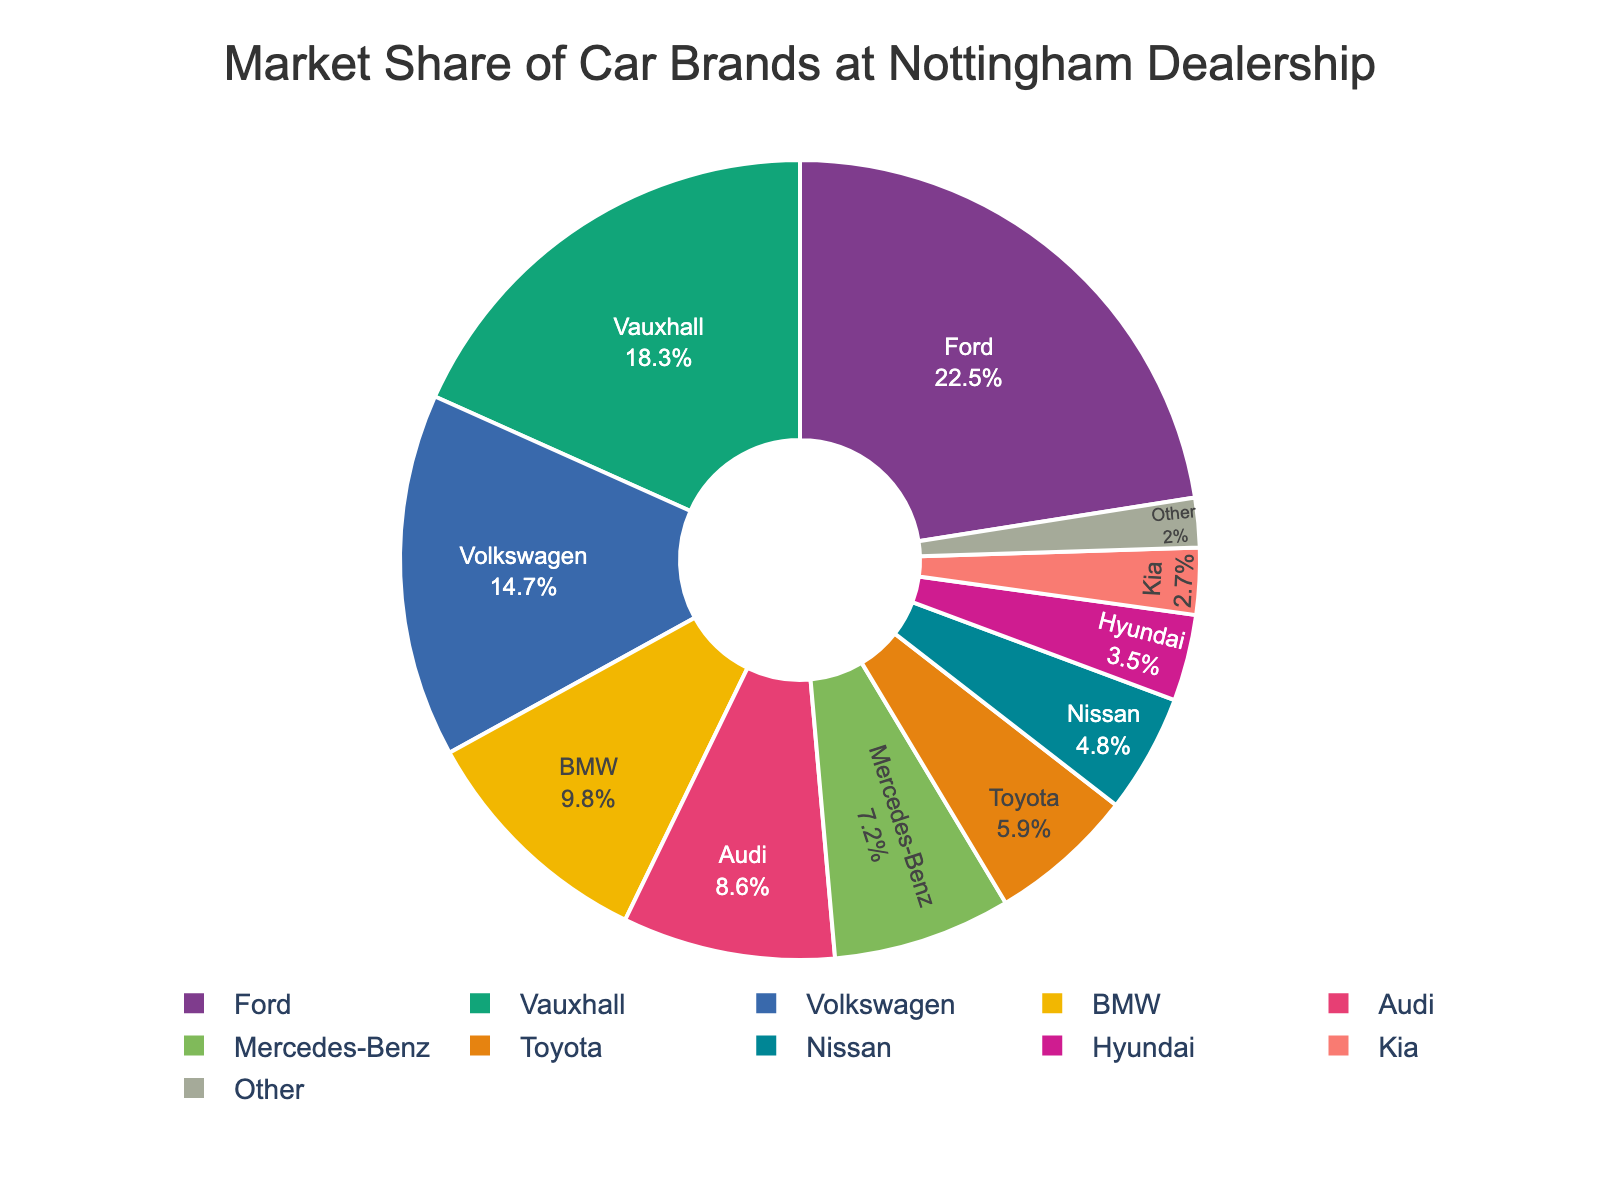What is the market share percentage of Vauxhall? Look at the segment labeled "Vauxhall" and read the percentage indicated.
Answer: 18.3% Which car brand has the highest market share? Identify the segment with the largest area. The label on this segment will indicate the car brand with the highest market share.
Answer: Ford What is the combined market share of Ford and Volkswagen? Find the segments labeled "Ford" and "Volkswagen" and add their percentages: Ford (22.5%) + Volkswagen (14.7%) = 37.2%.
Answer: 37.2% Which has a larger market share, Audi or Nissan, and by how much? Compare the percentages for Audi (8.6%) and Nissan (4.8%). Subtract the smaller percentage from the larger: 8.6% - 4.8% = 3.8%.
Answer: Audi by 3.8% What is the total market share of all brands other than Ford and Vauxhall? Sum the percentages of all brands except Ford (22.5%) and Vauxhall (18.3%): Add 14.7% + 9.8% + 8.6% + 7.2% + 5.9% + 4.8% + 3.5% + 2.7% + 2.0% = 54.2%.
Answer: 54.2% Which brand has the smallest market share, and what is it? Look for the smallest segment in the pie chart and identify the brand and its labeled percentage.
Answer: Other, 2.0% Among BMW, Toyota, and Kia, which brand has the median market share? Arrange the percentages in ascending order: Kia (2.7%), Toyota (5.9%), BMW (9.8%). The median is the middle number, which is Toyota's percentage.
Answer: Toyota Is the market share of Hyundai closer to that of Nissan or Kia? Compare the differences between Hyundai (3.5%) and Nissan (4.8%) as well as Hyundai and Kia (2.7%): 4.8% - 3.5% = 1.3%, 3.5% - 2.7% = 0.8%. Hyundai is closer to Kia.
Answer: Kia What percentage of the market share is represented by premium brands (BMW, Audi, Mercedes-Benz)? Sum the percentages of BMW (9.8%), Audi (8.6%), and Mercedes-Benz (7.2%): 9.8% + 8.6% + 7.2% = 25.6%.
Answer: 25.6% If the market share of Vauxhall increased by 5 percentage points, what would be its new market share? Add 5 percentage points to Vauxhall's current market share of 18.3%: 18.3% + 5% = 23.3%.
Answer: 23.3% 